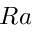Convert formula to latex. <formula><loc_0><loc_0><loc_500><loc_500>R a</formula> 